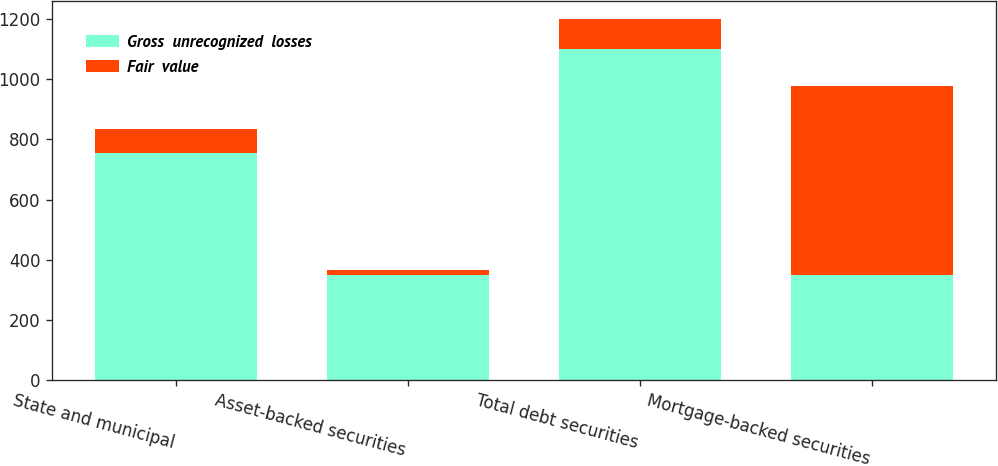<chart> <loc_0><loc_0><loc_500><loc_500><stacked_bar_chart><ecel><fcel>State and municipal<fcel>Asset-backed securities<fcel>Total debt securities<fcel>Mortgage-backed securities<nl><fcel>Gross  unrecognized  losses<fcel>755<fcel>348<fcel>1103<fcel>348<nl><fcel>Fair  value<fcel>79<fcel>18<fcel>97<fcel>631<nl></chart> 